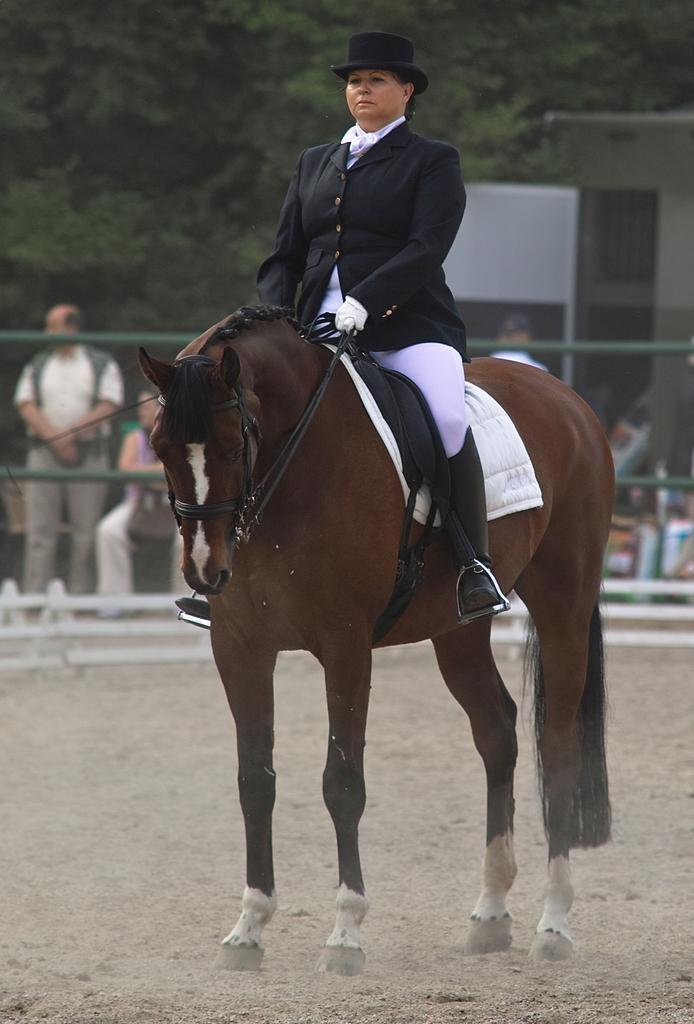How would you summarize this image in a sentence or two? This picture shows a woman is seated on the horse, in the background we can find a fence and couple of people, few are seated and few are standing, and also we can see a notice board and couple of trees. 